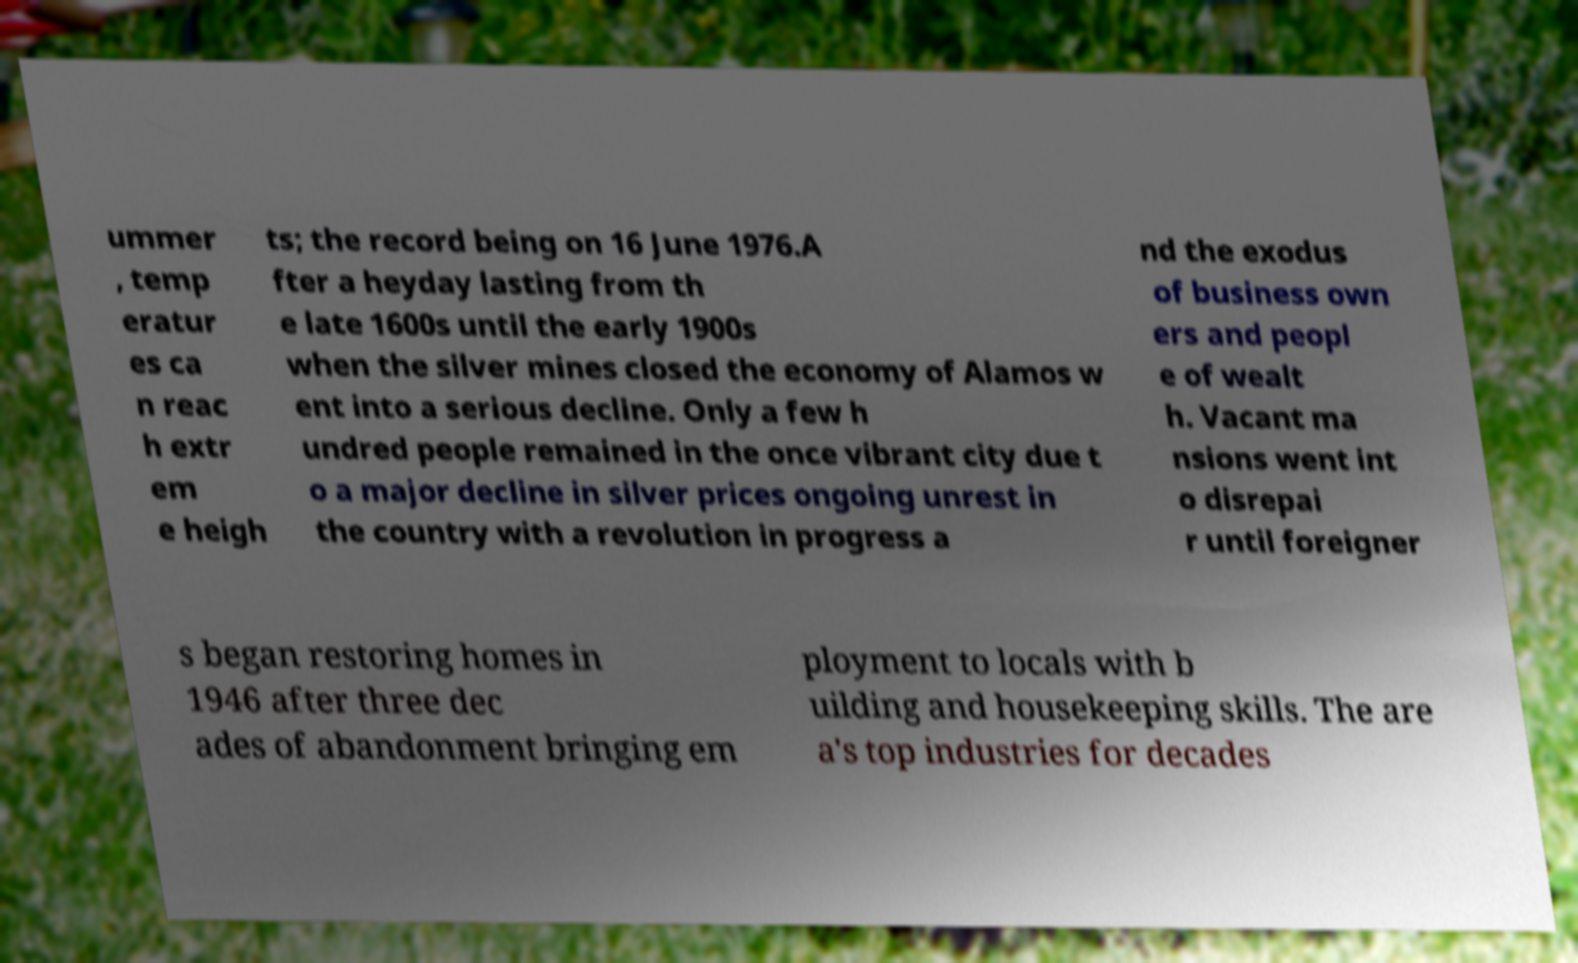Please identify and transcribe the text found in this image. ummer , temp eratur es ca n reac h extr em e heigh ts; the record being on 16 June 1976.A fter a heyday lasting from th e late 1600s until the early 1900s when the silver mines closed the economy of Alamos w ent into a serious decline. Only a few h undred people remained in the once vibrant city due t o a major decline in silver prices ongoing unrest in the country with a revolution in progress a nd the exodus of business own ers and peopl e of wealt h. Vacant ma nsions went int o disrepai r until foreigner s began restoring homes in 1946 after three dec ades of abandonment bringing em ployment to locals with b uilding and housekeeping skills. The are a's top industries for decades 